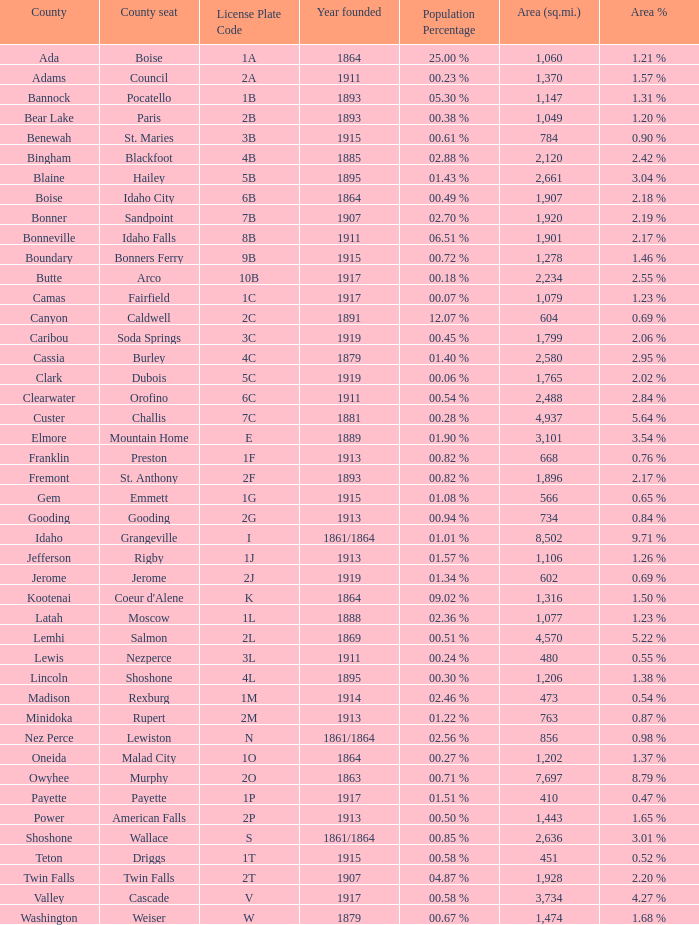What is the nation's location for the license plate code 5c? Dubois. 